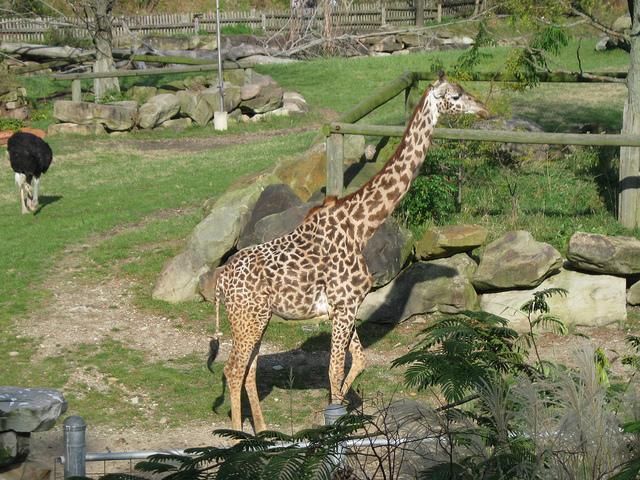How many giraffes are visible?
Give a very brief answer. 1. How many giraffes are there?
Give a very brief answer. 1. How many people are wearing red?
Give a very brief answer. 0. 